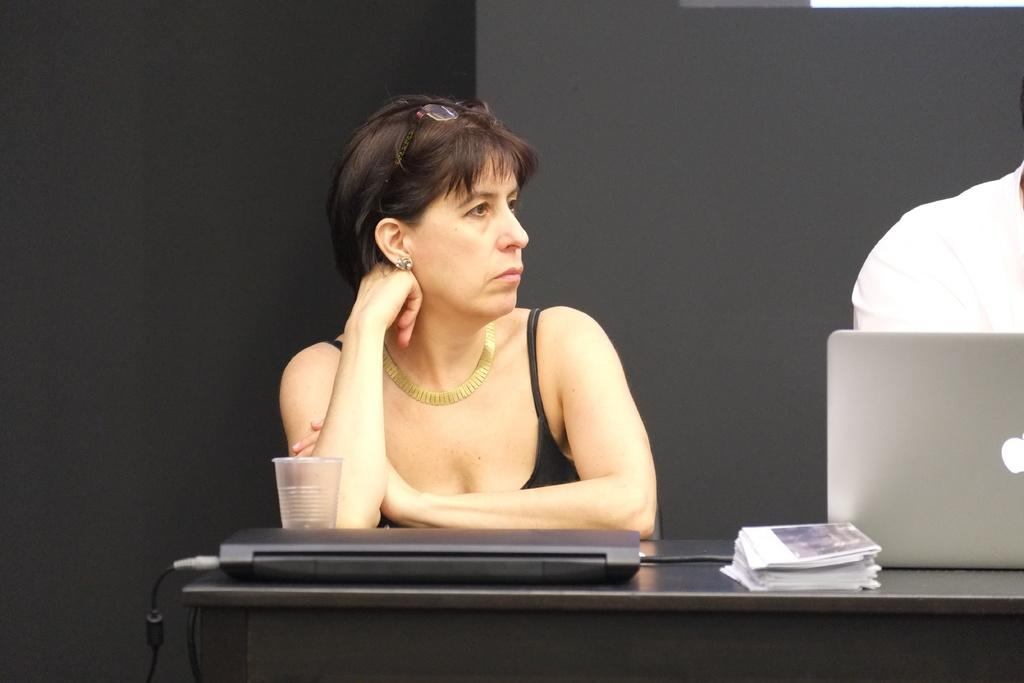Who is present in the image? There is a woman in the image. What object is on the table in the image? There is a laptop and a glass on the table in the image. What type of lettuce is being used as a knee support in the image? There is no lettuce or knee support present in the image. 